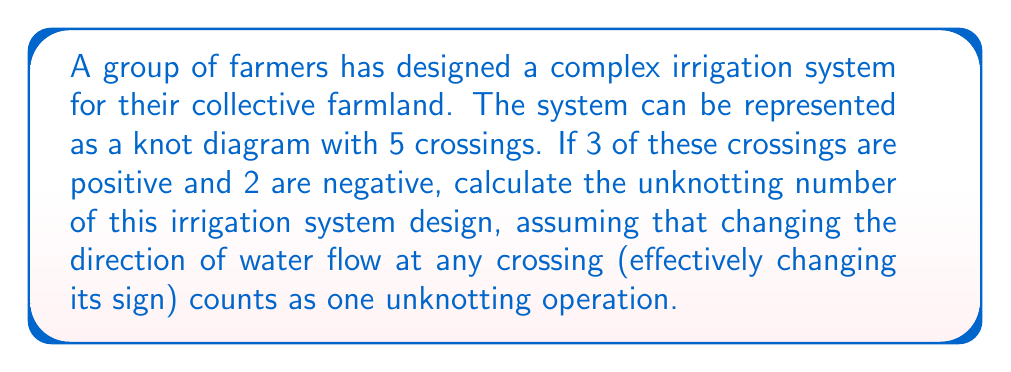What is the answer to this math problem? To calculate the unknotting number of this irrigation system design, we need to follow these steps:

1. Understand the given information:
   - The irrigation system is represented as a knot with 5 crossings
   - 3 crossings are positive, 2 are negative
   - Changing the direction of water flow (changing a crossing's sign) counts as one unknotting operation

2. Calculate the writhe of the knot:
   The writhe is the sum of the signs of all crossings.
   $$\text{Writhe} = (\text{Number of positive crossings}) - (\text{Number of negative crossings})$$
   $$\text{Writhe} = 3 - 2 = 1$$

3. Determine the lower bound for the unknotting number:
   For any knot, the absolute value of the writhe provides a lower bound for the unknotting number.
   $$\text{Lower bound} = |\text{Writhe}| = |1| = 1$$

4. Consider the upper bound:
   In the worst case, we would need to change all crossings to unknot the system. However, we only need to change the sign of crossings until we reach a total of 0 or all positive/negative crossings.

5. Calculate the minimum number of changes needed:
   We need to change 1 positive crossing to negative to balance the writhe:
   $$(3-1) - (2+1) = 0$$

6. Conclude:
   The unknotting number is at least 1 (from the lower bound) and at most 1 (from our calculation in step 5). Therefore, the unknotting number must be exactly 1.
Answer: 1 